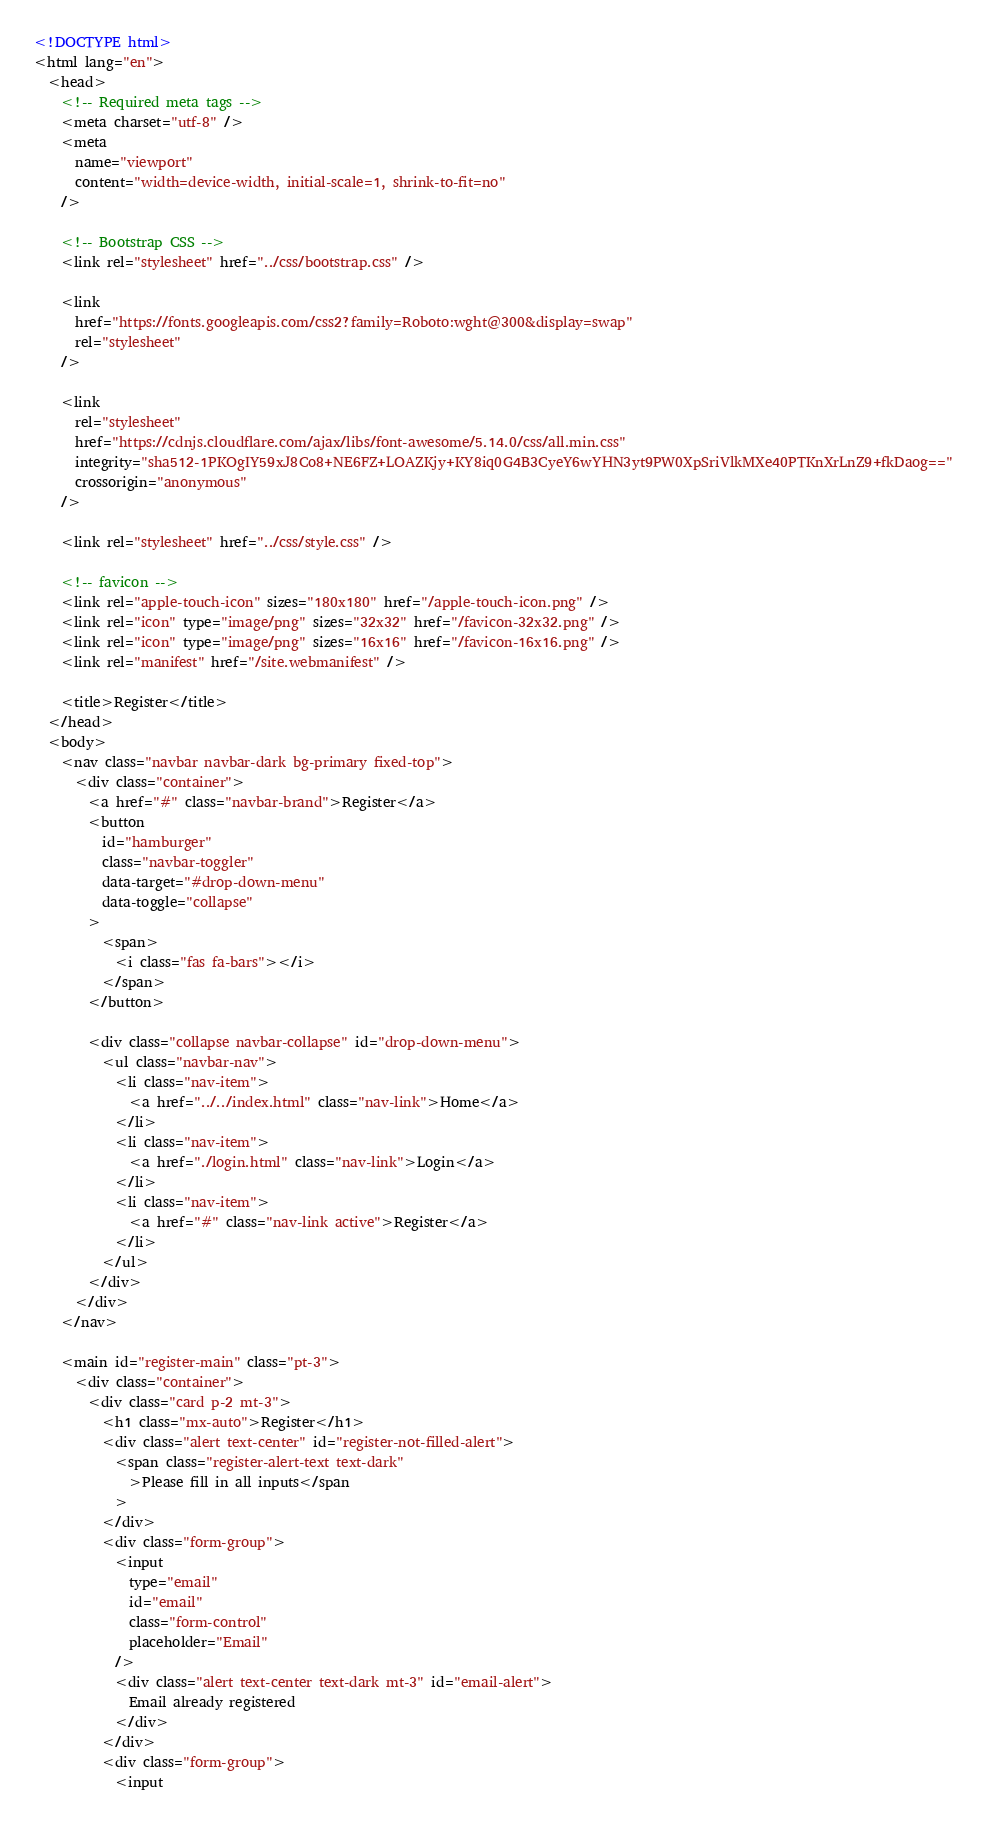<code> <loc_0><loc_0><loc_500><loc_500><_HTML_><!DOCTYPE html>
<html lang="en">
  <head>
    <!-- Required meta tags -->
    <meta charset="utf-8" />
    <meta
      name="viewport"
      content="width=device-width, initial-scale=1, shrink-to-fit=no"
    />

    <!-- Bootstrap CSS -->
    <link rel="stylesheet" href="../css/bootstrap.css" />

    <link
      href="https://fonts.googleapis.com/css2?family=Roboto:wght@300&display=swap"
      rel="stylesheet"
    />

    <link
      rel="stylesheet"
      href="https://cdnjs.cloudflare.com/ajax/libs/font-awesome/5.14.0/css/all.min.css"
      integrity="sha512-1PKOgIY59xJ8Co8+NE6FZ+LOAZKjy+KY8iq0G4B3CyeY6wYHN3yt9PW0XpSriVlkMXe40PTKnXrLnZ9+fkDaog=="
      crossorigin="anonymous"
    />

    <link rel="stylesheet" href="../css/style.css" />

    <!-- favicon -->
    <link rel="apple-touch-icon" sizes="180x180" href="/apple-touch-icon.png" />
    <link rel="icon" type="image/png" sizes="32x32" href="/favicon-32x32.png" />
    <link rel="icon" type="image/png" sizes="16x16" href="/favicon-16x16.png" />
    <link rel="manifest" href="/site.webmanifest" />

    <title>Register</title>
  </head>
  <body>
    <nav class="navbar navbar-dark bg-primary fixed-top">
      <div class="container">
        <a href="#" class="navbar-brand">Register</a>
        <button
          id="hamburger"
          class="navbar-toggler"
          data-target="#drop-down-menu"
          data-toggle="collapse"
        >
          <span>
            <i class="fas fa-bars"></i>
          </span>
        </button>

        <div class="collapse navbar-collapse" id="drop-down-menu">
          <ul class="navbar-nav">
            <li class="nav-item">
              <a href="../../index.html" class="nav-link">Home</a>
            </li>
            <li class="nav-item">
              <a href="./login.html" class="nav-link">Login</a>
            </li>
            <li class="nav-item">
              <a href="#" class="nav-link active">Register</a>
            </li>
          </ul>
        </div>
      </div>
    </nav>

    <main id="register-main" class="pt-3">
      <div class="container">
        <div class="card p-2 mt-3">
          <h1 class="mx-auto">Register</h1>
          <div class="alert text-center" id="register-not-filled-alert">
            <span class="register-alert-text text-dark"
              >Please fill in all inputs</span
            >
          </div>
          <div class="form-group">
            <input
              type="email"
              id="email"
              class="form-control"
              placeholder="Email"
            />
            <div class="alert text-center text-dark mt-3" id="email-alert">
              Email already registered
            </div>
          </div>
          <div class="form-group">
            <input</code> 